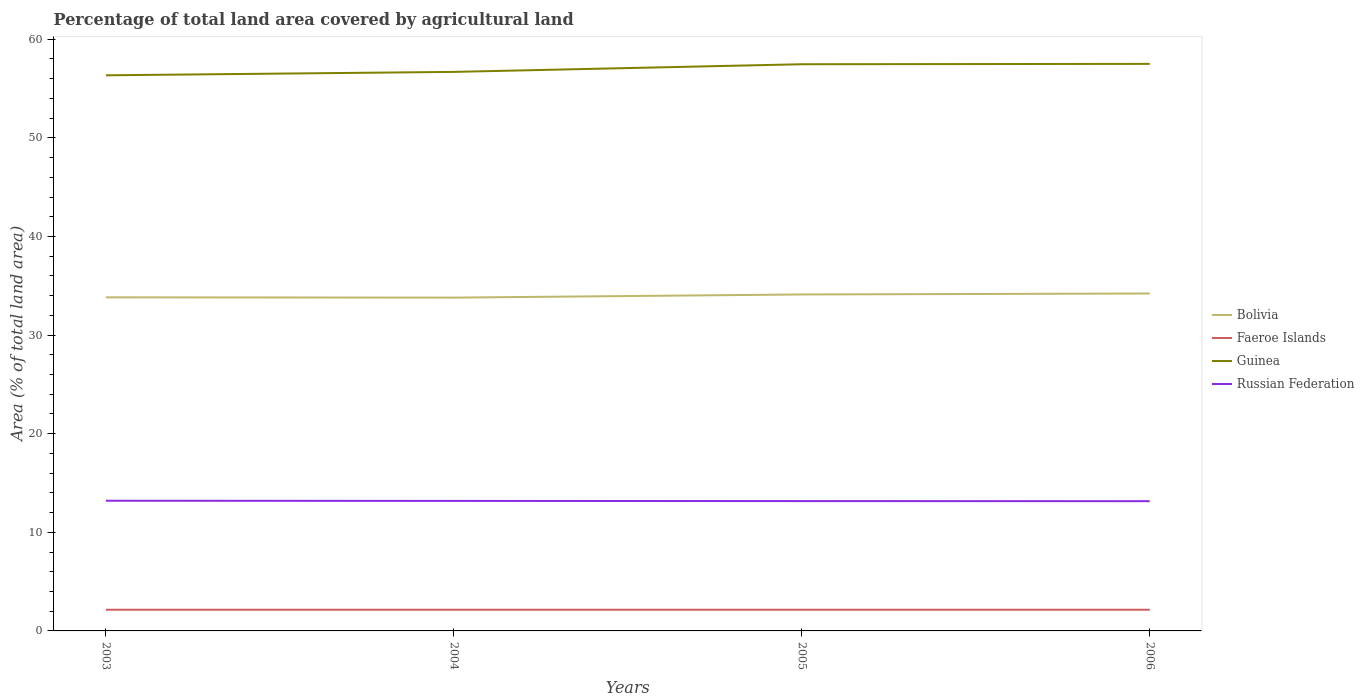How many different coloured lines are there?
Give a very brief answer. 4. Does the line corresponding to Russian Federation intersect with the line corresponding to Guinea?
Offer a terse response. No. Across all years, what is the maximum percentage of agricultural land in Faeroe Islands?
Provide a short and direct response. 2.15. What is the total percentage of agricultural land in Bolivia in the graph?
Make the answer very short. -0.1. What is the difference between the highest and the second highest percentage of agricultural land in Russian Federation?
Offer a terse response. 0.05. How many lines are there?
Your answer should be very brief. 4. What is the difference between two consecutive major ticks on the Y-axis?
Keep it short and to the point. 10. Does the graph contain any zero values?
Your answer should be very brief. No. Does the graph contain grids?
Make the answer very short. No. What is the title of the graph?
Offer a very short reply. Percentage of total land area covered by agricultural land. Does "European Union" appear as one of the legend labels in the graph?
Keep it short and to the point. No. What is the label or title of the Y-axis?
Your answer should be compact. Area (% of total land area). What is the Area (% of total land area) of Bolivia in 2003?
Make the answer very short. 33.83. What is the Area (% of total land area) in Faeroe Islands in 2003?
Offer a terse response. 2.15. What is the Area (% of total land area) of Guinea in 2003?
Provide a succinct answer. 56.34. What is the Area (% of total land area) in Russian Federation in 2003?
Your answer should be compact. 13.2. What is the Area (% of total land area) of Bolivia in 2004?
Your answer should be compact. 33.8. What is the Area (% of total land area) of Faeroe Islands in 2004?
Provide a succinct answer. 2.15. What is the Area (% of total land area) in Guinea in 2004?
Make the answer very short. 56.69. What is the Area (% of total land area) in Russian Federation in 2004?
Provide a succinct answer. 13.18. What is the Area (% of total land area) in Bolivia in 2005?
Offer a terse response. 34.12. What is the Area (% of total land area) in Faeroe Islands in 2005?
Offer a very short reply. 2.15. What is the Area (% of total land area) in Guinea in 2005?
Offer a terse response. 57.47. What is the Area (% of total land area) in Russian Federation in 2005?
Make the answer very short. 13.17. What is the Area (% of total land area) of Bolivia in 2006?
Keep it short and to the point. 34.22. What is the Area (% of total land area) of Faeroe Islands in 2006?
Provide a succinct answer. 2.15. What is the Area (% of total land area) of Guinea in 2006?
Your answer should be compact. 57.5. What is the Area (% of total land area) in Russian Federation in 2006?
Your answer should be compact. 13.16. Across all years, what is the maximum Area (% of total land area) in Bolivia?
Provide a succinct answer. 34.22. Across all years, what is the maximum Area (% of total land area) in Faeroe Islands?
Keep it short and to the point. 2.15. Across all years, what is the maximum Area (% of total land area) in Guinea?
Give a very brief answer. 57.5. Across all years, what is the maximum Area (% of total land area) in Russian Federation?
Your response must be concise. 13.2. Across all years, what is the minimum Area (% of total land area) in Bolivia?
Provide a short and direct response. 33.8. Across all years, what is the minimum Area (% of total land area) in Faeroe Islands?
Your response must be concise. 2.15. Across all years, what is the minimum Area (% of total land area) of Guinea?
Your answer should be compact. 56.34. Across all years, what is the minimum Area (% of total land area) of Russian Federation?
Provide a succinct answer. 13.16. What is the total Area (% of total land area) of Bolivia in the graph?
Provide a succinct answer. 135.97. What is the total Area (% of total land area) of Faeroe Islands in the graph?
Ensure brevity in your answer.  8.6. What is the total Area (% of total land area) in Guinea in the graph?
Offer a very short reply. 228.01. What is the total Area (% of total land area) in Russian Federation in the graph?
Offer a terse response. 52.71. What is the difference between the Area (% of total land area) of Bolivia in 2003 and that in 2004?
Offer a very short reply. 0.03. What is the difference between the Area (% of total land area) in Guinea in 2003 and that in 2004?
Keep it short and to the point. -0.35. What is the difference between the Area (% of total land area) in Russian Federation in 2003 and that in 2004?
Keep it short and to the point. 0.02. What is the difference between the Area (% of total land area) of Bolivia in 2003 and that in 2005?
Ensure brevity in your answer.  -0.29. What is the difference between the Area (% of total land area) in Guinea in 2003 and that in 2005?
Your answer should be compact. -1.12. What is the difference between the Area (% of total land area) in Russian Federation in 2003 and that in 2005?
Your response must be concise. 0.04. What is the difference between the Area (% of total land area) of Bolivia in 2003 and that in 2006?
Keep it short and to the point. -0.39. What is the difference between the Area (% of total land area) in Guinea in 2003 and that in 2006?
Give a very brief answer. -1.16. What is the difference between the Area (% of total land area) of Russian Federation in 2003 and that in 2006?
Your answer should be very brief. 0.05. What is the difference between the Area (% of total land area) of Bolivia in 2004 and that in 2005?
Ensure brevity in your answer.  -0.32. What is the difference between the Area (% of total land area) of Guinea in 2004 and that in 2005?
Make the answer very short. -0.78. What is the difference between the Area (% of total land area) in Russian Federation in 2004 and that in 2005?
Offer a terse response. 0.02. What is the difference between the Area (% of total land area) of Bolivia in 2004 and that in 2006?
Make the answer very short. -0.42. What is the difference between the Area (% of total land area) in Faeroe Islands in 2004 and that in 2006?
Your response must be concise. 0. What is the difference between the Area (% of total land area) of Guinea in 2004 and that in 2006?
Provide a succinct answer. -0.81. What is the difference between the Area (% of total land area) in Russian Federation in 2004 and that in 2006?
Offer a very short reply. 0.03. What is the difference between the Area (% of total land area) in Bolivia in 2005 and that in 2006?
Offer a very short reply. -0.1. What is the difference between the Area (% of total land area) of Faeroe Islands in 2005 and that in 2006?
Provide a succinct answer. 0. What is the difference between the Area (% of total land area) in Guinea in 2005 and that in 2006?
Make the answer very short. -0.04. What is the difference between the Area (% of total land area) in Russian Federation in 2005 and that in 2006?
Ensure brevity in your answer.  0.01. What is the difference between the Area (% of total land area) of Bolivia in 2003 and the Area (% of total land area) of Faeroe Islands in 2004?
Provide a succinct answer. 31.68. What is the difference between the Area (% of total land area) of Bolivia in 2003 and the Area (% of total land area) of Guinea in 2004?
Your response must be concise. -22.86. What is the difference between the Area (% of total land area) of Bolivia in 2003 and the Area (% of total land area) of Russian Federation in 2004?
Your answer should be compact. 20.64. What is the difference between the Area (% of total land area) of Faeroe Islands in 2003 and the Area (% of total land area) of Guinea in 2004?
Your answer should be compact. -54.54. What is the difference between the Area (% of total land area) of Faeroe Islands in 2003 and the Area (% of total land area) of Russian Federation in 2004?
Give a very brief answer. -11.04. What is the difference between the Area (% of total land area) of Guinea in 2003 and the Area (% of total land area) of Russian Federation in 2004?
Provide a succinct answer. 43.16. What is the difference between the Area (% of total land area) of Bolivia in 2003 and the Area (% of total land area) of Faeroe Islands in 2005?
Give a very brief answer. 31.68. What is the difference between the Area (% of total land area) of Bolivia in 2003 and the Area (% of total land area) of Guinea in 2005?
Offer a very short reply. -23.64. What is the difference between the Area (% of total land area) in Bolivia in 2003 and the Area (% of total land area) in Russian Federation in 2005?
Your answer should be compact. 20.66. What is the difference between the Area (% of total land area) in Faeroe Islands in 2003 and the Area (% of total land area) in Guinea in 2005?
Offer a terse response. -55.32. What is the difference between the Area (% of total land area) in Faeroe Islands in 2003 and the Area (% of total land area) in Russian Federation in 2005?
Ensure brevity in your answer.  -11.02. What is the difference between the Area (% of total land area) of Guinea in 2003 and the Area (% of total land area) of Russian Federation in 2005?
Your response must be concise. 43.18. What is the difference between the Area (% of total land area) in Bolivia in 2003 and the Area (% of total land area) in Faeroe Islands in 2006?
Your response must be concise. 31.68. What is the difference between the Area (% of total land area) in Bolivia in 2003 and the Area (% of total land area) in Guinea in 2006?
Offer a very short reply. -23.68. What is the difference between the Area (% of total land area) in Bolivia in 2003 and the Area (% of total land area) in Russian Federation in 2006?
Your answer should be very brief. 20.67. What is the difference between the Area (% of total land area) in Faeroe Islands in 2003 and the Area (% of total land area) in Guinea in 2006?
Offer a terse response. -55.36. What is the difference between the Area (% of total land area) in Faeroe Islands in 2003 and the Area (% of total land area) in Russian Federation in 2006?
Offer a terse response. -11.01. What is the difference between the Area (% of total land area) of Guinea in 2003 and the Area (% of total land area) of Russian Federation in 2006?
Your answer should be very brief. 43.19. What is the difference between the Area (% of total land area) in Bolivia in 2004 and the Area (% of total land area) in Faeroe Islands in 2005?
Keep it short and to the point. 31.65. What is the difference between the Area (% of total land area) of Bolivia in 2004 and the Area (% of total land area) of Guinea in 2005?
Offer a very short reply. -23.67. What is the difference between the Area (% of total land area) of Bolivia in 2004 and the Area (% of total land area) of Russian Federation in 2005?
Your answer should be compact. 20.64. What is the difference between the Area (% of total land area) in Faeroe Islands in 2004 and the Area (% of total land area) in Guinea in 2005?
Ensure brevity in your answer.  -55.32. What is the difference between the Area (% of total land area) in Faeroe Islands in 2004 and the Area (% of total land area) in Russian Federation in 2005?
Provide a short and direct response. -11.02. What is the difference between the Area (% of total land area) in Guinea in 2004 and the Area (% of total land area) in Russian Federation in 2005?
Ensure brevity in your answer.  43.52. What is the difference between the Area (% of total land area) in Bolivia in 2004 and the Area (% of total land area) in Faeroe Islands in 2006?
Provide a short and direct response. 31.65. What is the difference between the Area (% of total land area) in Bolivia in 2004 and the Area (% of total land area) in Guinea in 2006?
Make the answer very short. -23.7. What is the difference between the Area (% of total land area) of Bolivia in 2004 and the Area (% of total land area) of Russian Federation in 2006?
Your answer should be very brief. 20.64. What is the difference between the Area (% of total land area) of Faeroe Islands in 2004 and the Area (% of total land area) of Guinea in 2006?
Provide a succinct answer. -55.36. What is the difference between the Area (% of total land area) in Faeroe Islands in 2004 and the Area (% of total land area) in Russian Federation in 2006?
Your response must be concise. -11.01. What is the difference between the Area (% of total land area) of Guinea in 2004 and the Area (% of total land area) of Russian Federation in 2006?
Your answer should be compact. 43.53. What is the difference between the Area (% of total land area) in Bolivia in 2005 and the Area (% of total land area) in Faeroe Islands in 2006?
Provide a succinct answer. 31.97. What is the difference between the Area (% of total land area) of Bolivia in 2005 and the Area (% of total land area) of Guinea in 2006?
Your response must be concise. -23.38. What is the difference between the Area (% of total land area) of Bolivia in 2005 and the Area (% of total land area) of Russian Federation in 2006?
Keep it short and to the point. 20.96. What is the difference between the Area (% of total land area) of Faeroe Islands in 2005 and the Area (% of total land area) of Guinea in 2006?
Ensure brevity in your answer.  -55.36. What is the difference between the Area (% of total land area) of Faeroe Islands in 2005 and the Area (% of total land area) of Russian Federation in 2006?
Ensure brevity in your answer.  -11.01. What is the difference between the Area (% of total land area) in Guinea in 2005 and the Area (% of total land area) in Russian Federation in 2006?
Ensure brevity in your answer.  44.31. What is the average Area (% of total land area) of Bolivia per year?
Make the answer very short. 33.99. What is the average Area (% of total land area) in Faeroe Islands per year?
Your answer should be compact. 2.15. What is the average Area (% of total land area) of Guinea per year?
Ensure brevity in your answer.  57. What is the average Area (% of total land area) of Russian Federation per year?
Your answer should be compact. 13.18. In the year 2003, what is the difference between the Area (% of total land area) in Bolivia and Area (% of total land area) in Faeroe Islands?
Your answer should be compact. 31.68. In the year 2003, what is the difference between the Area (% of total land area) in Bolivia and Area (% of total land area) in Guinea?
Offer a terse response. -22.52. In the year 2003, what is the difference between the Area (% of total land area) in Bolivia and Area (% of total land area) in Russian Federation?
Provide a short and direct response. 20.63. In the year 2003, what is the difference between the Area (% of total land area) of Faeroe Islands and Area (% of total land area) of Guinea?
Offer a terse response. -54.2. In the year 2003, what is the difference between the Area (% of total land area) of Faeroe Islands and Area (% of total land area) of Russian Federation?
Give a very brief answer. -11.05. In the year 2003, what is the difference between the Area (% of total land area) in Guinea and Area (% of total land area) in Russian Federation?
Ensure brevity in your answer.  43.14. In the year 2004, what is the difference between the Area (% of total land area) of Bolivia and Area (% of total land area) of Faeroe Islands?
Ensure brevity in your answer.  31.65. In the year 2004, what is the difference between the Area (% of total land area) in Bolivia and Area (% of total land area) in Guinea?
Provide a succinct answer. -22.89. In the year 2004, what is the difference between the Area (% of total land area) of Bolivia and Area (% of total land area) of Russian Federation?
Your response must be concise. 20.62. In the year 2004, what is the difference between the Area (% of total land area) in Faeroe Islands and Area (% of total land area) in Guinea?
Make the answer very short. -54.54. In the year 2004, what is the difference between the Area (% of total land area) of Faeroe Islands and Area (% of total land area) of Russian Federation?
Provide a short and direct response. -11.04. In the year 2004, what is the difference between the Area (% of total land area) in Guinea and Area (% of total land area) in Russian Federation?
Your response must be concise. 43.51. In the year 2005, what is the difference between the Area (% of total land area) of Bolivia and Area (% of total land area) of Faeroe Islands?
Ensure brevity in your answer.  31.97. In the year 2005, what is the difference between the Area (% of total land area) of Bolivia and Area (% of total land area) of Guinea?
Offer a very short reply. -23.35. In the year 2005, what is the difference between the Area (% of total land area) in Bolivia and Area (% of total land area) in Russian Federation?
Your answer should be very brief. 20.95. In the year 2005, what is the difference between the Area (% of total land area) in Faeroe Islands and Area (% of total land area) in Guinea?
Give a very brief answer. -55.32. In the year 2005, what is the difference between the Area (% of total land area) in Faeroe Islands and Area (% of total land area) in Russian Federation?
Offer a terse response. -11.02. In the year 2005, what is the difference between the Area (% of total land area) of Guinea and Area (% of total land area) of Russian Federation?
Your answer should be compact. 44.3. In the year 2006, what is the difference between the Area (% of total land area) in Bolivia and Area (% of total land area) in Faeroe Islands?
Keep it short and to the point. 32.07. In the year 2006, what is the difference between the Area (% of total land area) in Bolivia and Area (% of total land area) in Guinea?
Your response must be concise. -23.29. In the year 2006, what is the difference between the Area (% of total land area) in Bolivia and Area (% of total land area) in Russian Federation?
Make the answer very short. 21.06. In the year 2006, what is the difference between the Area (% of total land area) in Faeroe Islands and Area (% of total land area) in Guinea?
Provide a short and direct response. -55.36. In the year 2006, what is the difference between the Area (% of total land area) in Faeroe Islands and Area (% of total land area) in Russian Federation?
Your answer should be compact. -11.01. In the year 2006, what is the difference between the Area (% of total land area) in Guinea and Area (% of total land area) in Russian Federation?
Provide a succinct answer. 44.35. What is the ratio of the Area (% of total land area) of Bolivia in 2003 to that in 2004?
Ensure brevity in your answer.  1. What is the ratio of the Area (% of total land area) in Faeroe Islands in 2003 to that in 2004?
Your response must be concise. 1. What is the ratio of the Area (% of total land area) of Russian Federation in 2003 to that in 2004?
Ensure brevity in your answer.  1. What is the ratio of the Area (% of total land area) in Guinea in 2003 to that in 2005?
Ensure brevity in your answer.  0.98. What is the ratio of the Area (% of total land area) in Bolivia in 2003 to that in 2006?
Ensure brevity in your answer.  0.99. What is the ratio of the Area (% of total land area) in Guinea in 2003 to that in 2006?
Give a very brief answer. 0.98. What is the ratio of the Area (% of total land area) of Russian Federation in 2003 to that in 2006?
Give a very brief answer. 1. What is the ratio of the Area (% of total land area) of Bolivia in 2004 to that in 2005?
Make the answer very short. 0.99. What is the ratio of the Area (% of total land area) of Faeroe Islands in 2004 to that in 2005?
Give a very brief answer. 1. What is the ratio of the Area (% of total land area) of Guinea in 2004 to that in 2005?
Ensure brevity in your answer.  0.99. What is the ratio of the Area (% of total land area) of Faeroe Islands in 2004 to that in 2006?
Your response must be concise. 1. What is the ratio of the Area (% of total land area) of Guinea in 2004 to that in 2006?
Provide a short and direct response. 0.99. What is the ratio of the Area (% of total land area) of Bolivia in 2005 to that in 2006?
Ensure brevity in your answer.  1. What is the difference between the highest and the second highest Area (% of total land area) in Bolivia?
Ensure brevity in your answer.  0.1. What is the difference between the highest and the second highest Area (% of total land area) in Guinea?
Give a very brief answer. 0.04. What is the difference between the highest and the second highest Area (% of total land area) of Russian Federation?
Give a very brief answer. 0.02. What is the difference between the highest and the lowest Area (% of total land area) in Bolivia?
Provide a short and direct response. 0.42. What is the difference between the highest and the lowest Area (% of total land area) in Faeroe Islands?
Keep it short and to the point. 0. What is the difference between the highest and the lowest Area (% of total land area) of Guinea?
Make the answer very short. 1.16. What is the difference between the highest and the lowest Area (% of total land area) of Russian Federation?
Keep it short and to the point. 0.05. 